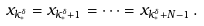<formula> <loc_0><loc_0><loc_500><loc_500>x _ { k _ { * } ^ { \delta } } = x _ { k _ { * } ^ { \delta } + 1 } = \dots = x _ { k _ { * } ^ { \delta } + N - 1 } \, .</formula> 